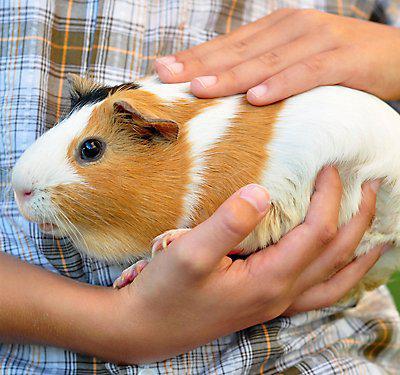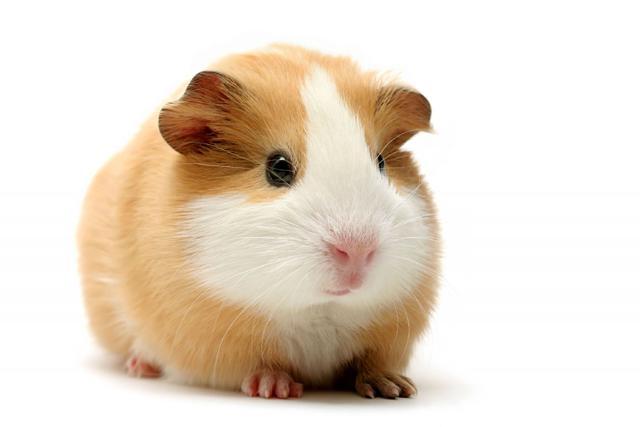The first image is the image on the left, the second image is the image on the right. Given the left and right images, does the statement "There are 2 hamsters in total" hold true? Answer yes or no. Yes. The first image is the image on the left, the second image is the image on the right. Analyze the images presented: Is the assertion "The animal in the image on the right is on a plain white background" valid? Answer yes or no. Yes. 